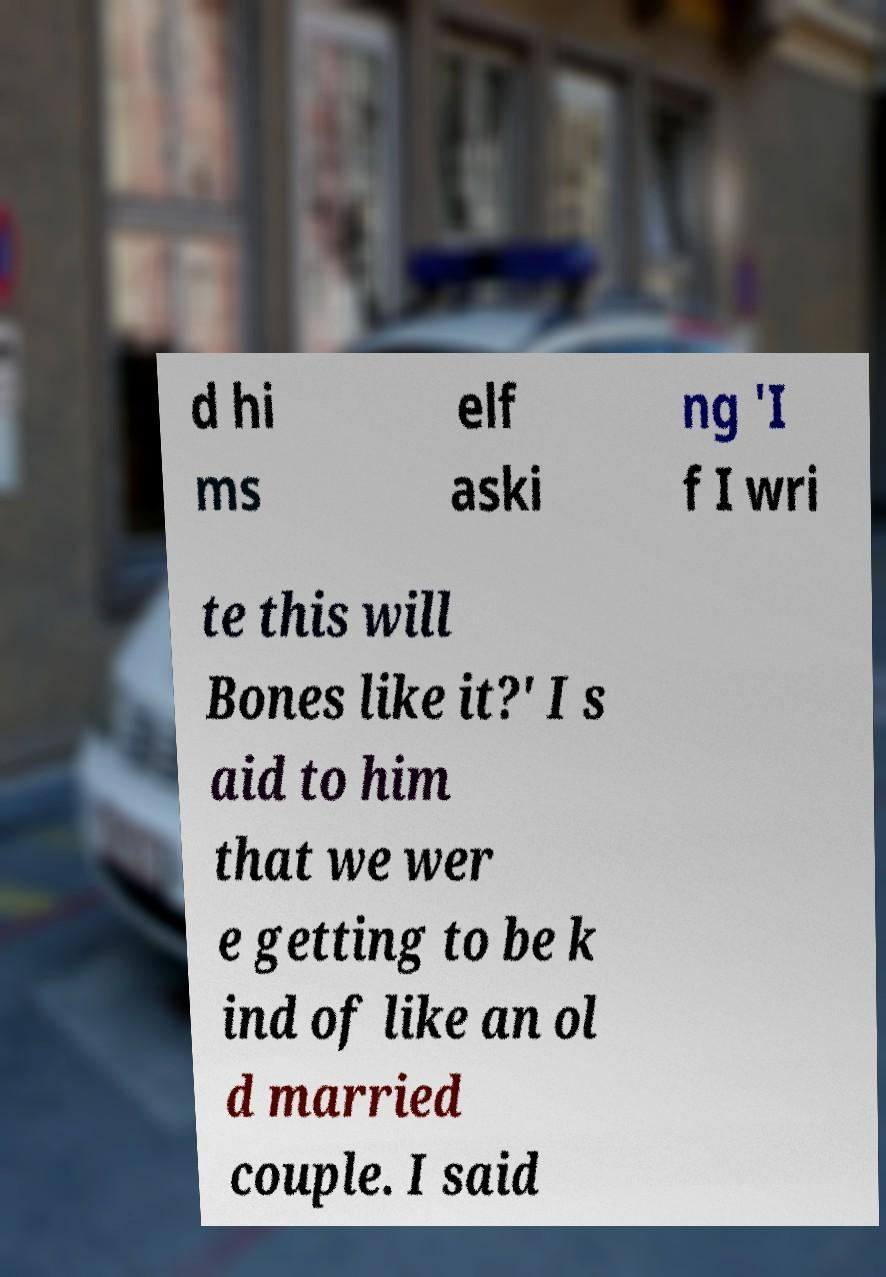Can you accurately transcribe the text from the provided image for me? d hi ms elf aski ng 'I f I wri te this will Bones like it?' I s aid to him that we wer e getting to be k ind of like an ol d married couple. I said 